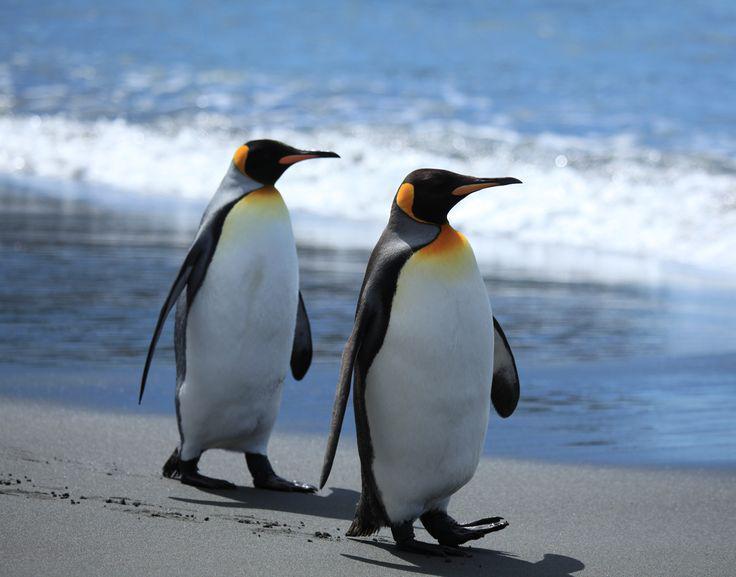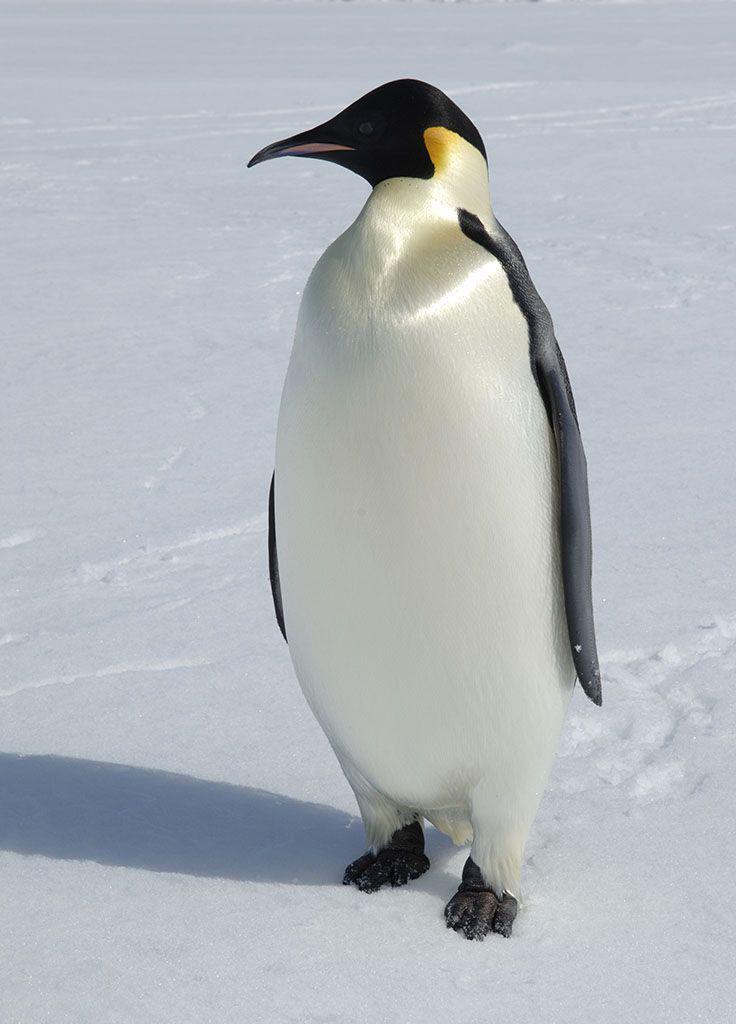The first image is the image on the left, the second image is the image on the right. Examine the images to the left and right. Is the description "Each image shows an upright penguin that is standing in one place rather than walking." accurate? Answer yes or no. No. The first image is the image on the left, the second image is the image on the right. Evaluate the accuracy of this statement regarding the images: "There is a penguin that is walking forward.". Is it true? Answer yes or no. Yes. 